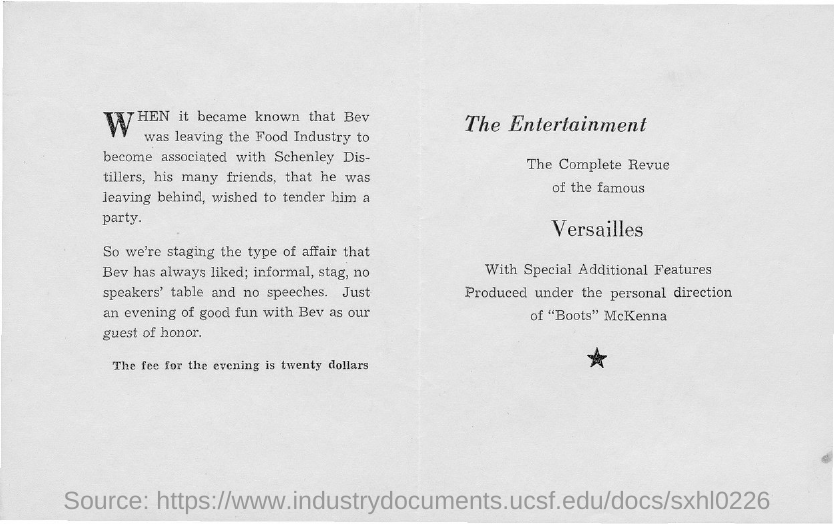What is the first title in the document?
Provide a succinct answer. The Entertainment. 